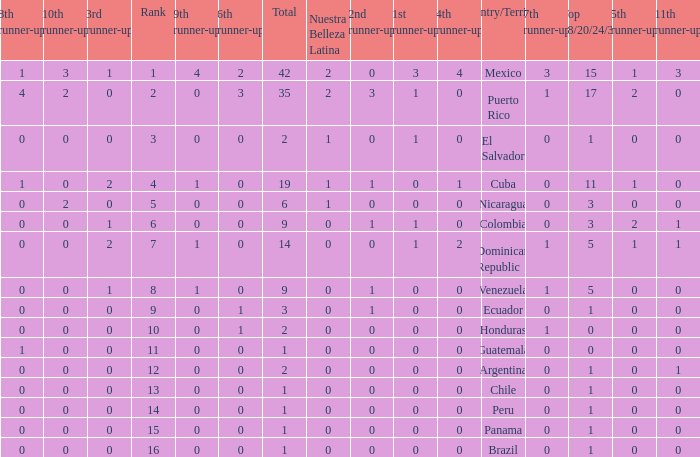What is the average total of the country with a 4th runner-up of 0 and a Nuestra Bellaza Latina less than 0? None. 